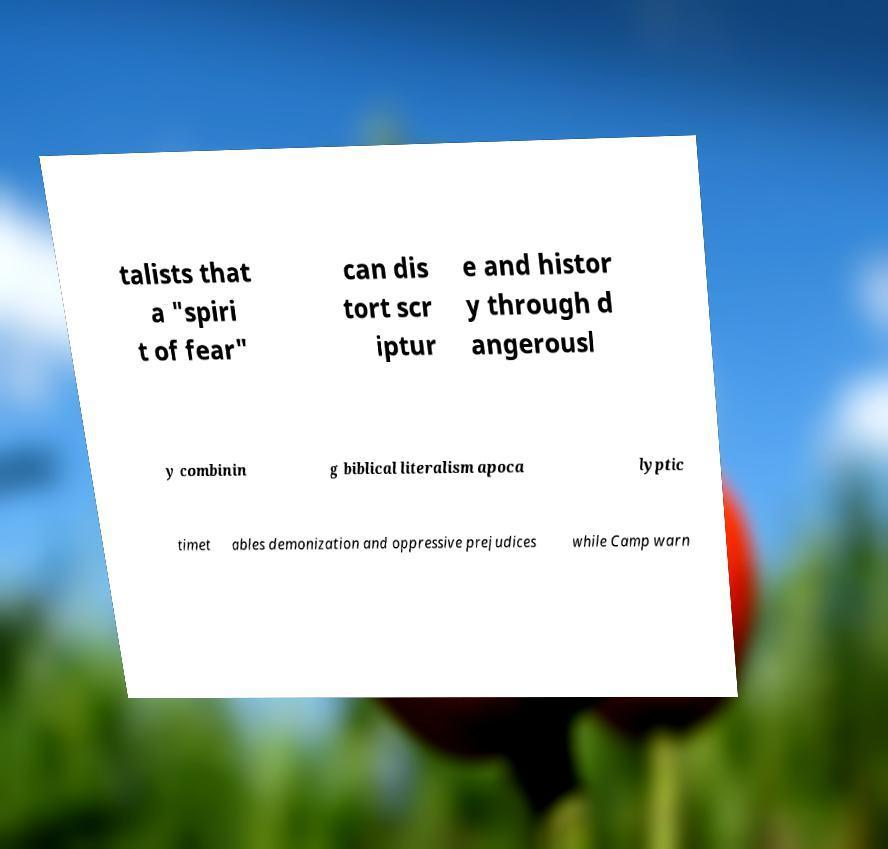What messages or text are displayed in this image? I need them in a readable, typed format. talists that a "spiri t of fear" can dis tort scr iptur e and histor y through d angerousl y combinin g biblical literalism apoca lyptic timet ables demonization and oppressive prejudices while Camp warn 